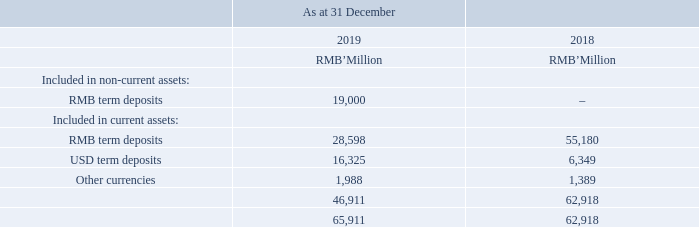TERM DEPOSITS
An analysis of the Group’s term deposits by currencies are as follows:
The effective interest rate for the term deposits of the Group with initial terms of over three months to three years during the year ended 31 December 2019 was 3.57% (2018: 4.08%).
Term deposits with initial terms of over three months were neither past due nor impaired. As at 31 December 2019, the carrying amounts of the term deposits with initial terms of over three months approximated their fair values.
What was the effective interest rate for the Group's term deposits during the year ended 31 December 2019? 3.57%. What was the effective interest rate for the term deposits of the Group with initial terms of over three months to three years during the year ended 31 December 2018? 4.08%. How much was the RMB term deposits included in non-current assets as at 31 December 2019?
Answer scale should be: million. 19,000. How much did the RMB term deposits included in current assets change by between 2018 year end and 2019 year end?
Answer scale should be: million. 28,598-55,180
Answer: -26582. How much did the USD term deposits included in current assets change by between 2018 year end and 2019 year end?
Answer scale should be: million. 16,325-6,349
Answer: 9976. How much did the total term deposits change by between 2018 year end and 2019 year end?
Answer scale should be: million. 65,911-62,918
Answer: 2993. 